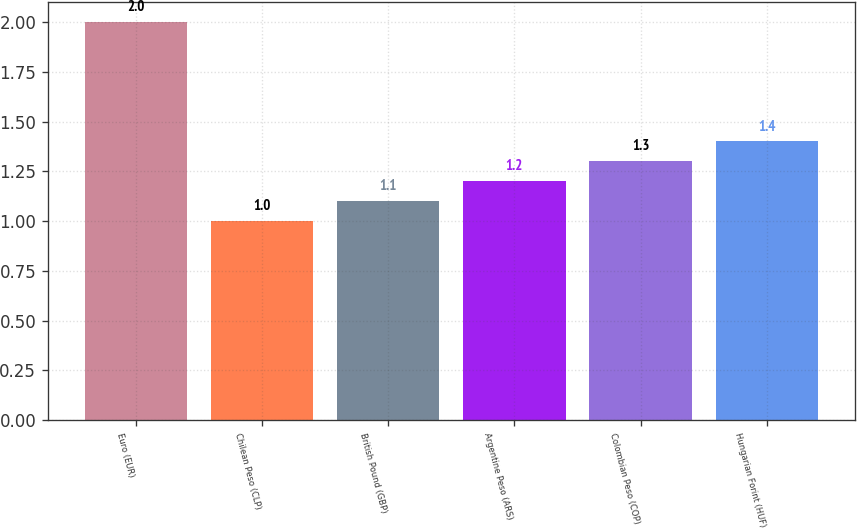Convert chart. <chart><loc_0><loc_0><loc_500><loc_500><bar_chart><fcel>Euro (EUR)<fcel>Chilean Peso (CLP)<fcel>British Pound (GBP)<fcel>Argentine Peso (ARS)<fcel>Colombian Peso (COP)<fcel>Hungarian Forint (HUF)<nl><fcel>2<fcel>1<fcel>1.1<fcel>1.2<fcel>1.3<fcel>1.4<nl></chart> 